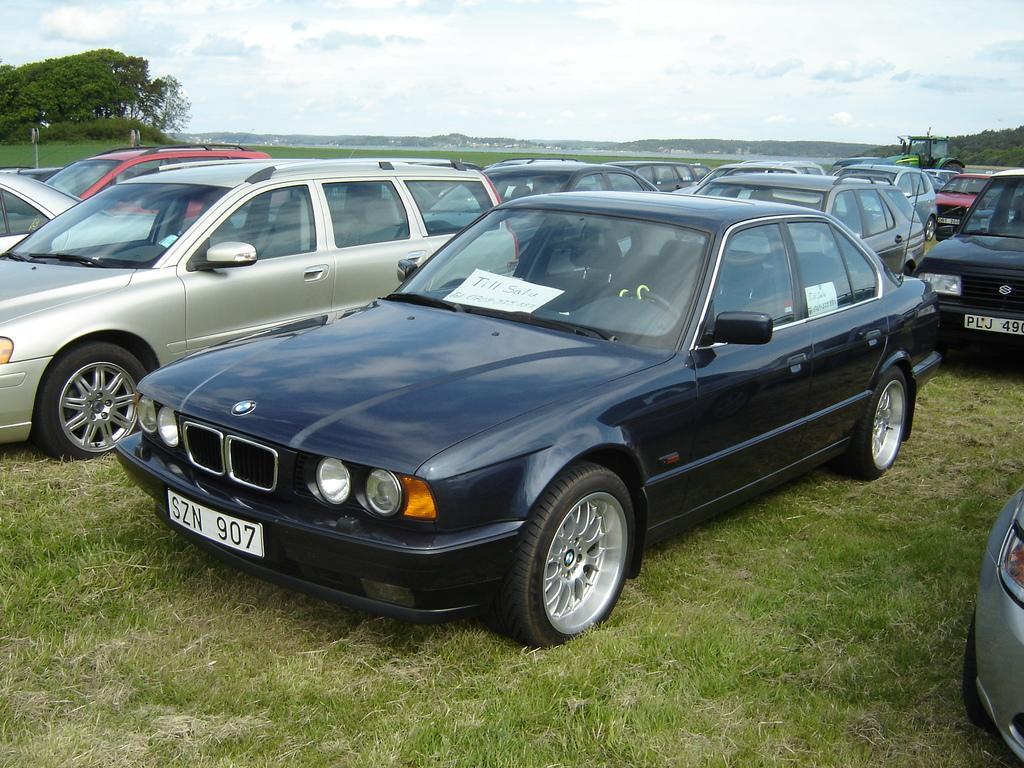Can you describe this image briefly? In this image in front there are cars. At the bottom of the image there is grass on the surface. In the background of the image there are trees, mountains, buildings and sky. 